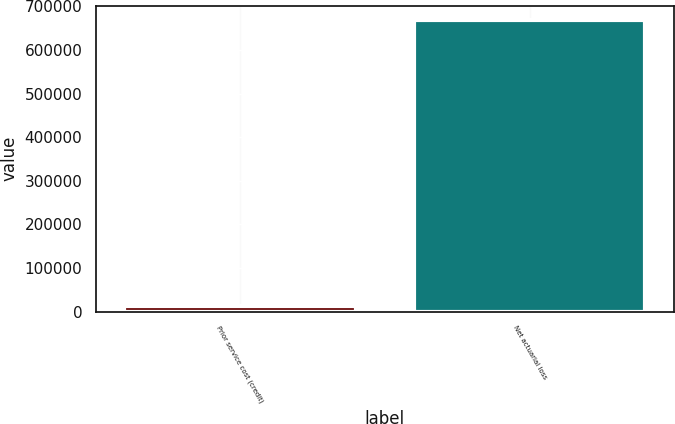<chart> <loc_0><loc_0><loc_500><loc_500><bar_chart><fcel>Prior service cost (credit)<fcel>Net actuarial loss<nl><fcel>12432<fcel>668285<nl></chart> 